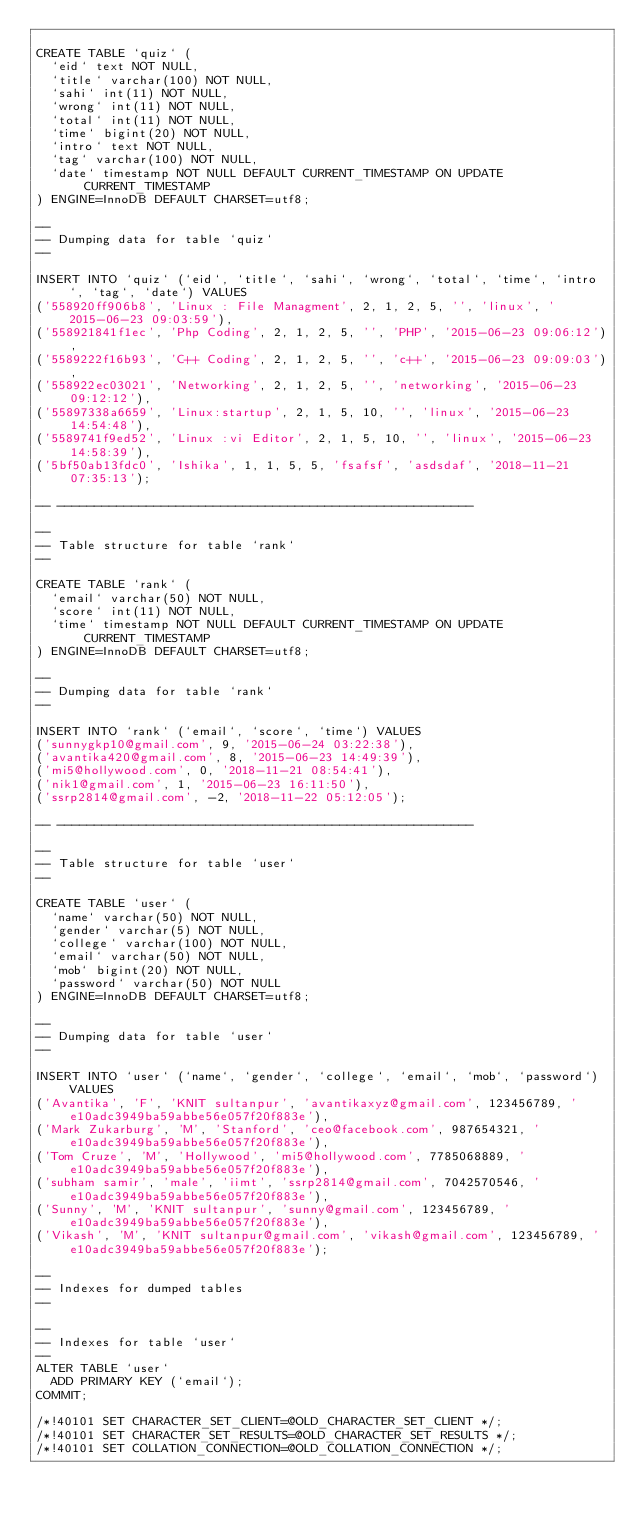<code> <loc_0><loc_0><loc_500><loc_500><_SQL_>
CREATE TABLE `quiz` (
  `eid` text NOT NULL,
  `title` varchar(100) NOT NULL,
  `sahi` int(11) NOT NULL,
  `wrong` int(11) NOT NULL,
  `total` int(11) NOT NULL,
  `time` bigint(20) NOT NULL,
  `intro` text NOT NULL,
  `tag` varchar(100) NOT NULL,
  `date` timestamp NOT NULL DEFAULT CURRENT_TIMESTAMP ON UPDATE CURRENT_TIMESTAMP
) ENGINE=InnoDB DEFAULT CHARSET=utf8;

--
-- Dumping data for table `quiz`
--

INSERT INTO `quiz` (`eid`, `title`, `sahi`, `wrong`, `total`, `time`, `intro`, `tag`, `date`) VALUES
('558920ff906b8', 'Linux : File Managment', 2, 1, 2, 5, '', 'linux', '2015-06-23 09:03:59'),
('558921841f1ec', 'Php Coding', 2, 1, 2, 5, '', 'PHP', '2015-06-23 09:06:12'),
('5589222f16b93', 'C++ Coding', 2, 1, 2, 5, '', 'c++', '2015-06-23 09:09:03'),
('558922ec03021', 'Networking', 2, 1, 2, 5, '', 'networking', '2015-06-23 09:12:12'),
('55897338a6659', 'Linux:startup', 2, 1, 5, 10, '', 'linux', '2015-06-23 14:54:48'),
('5589741f9ed52', 'Linux :vi Editor', 2, 1, 5, 10, '', 'linux', '2015-06-23 14:58:39'),
('5bf50ab13fdc0', 'Ishika', 1, 1, 5, 5, 'fsafsf', 'asdsdaf', '2018-11-21 07:35:13');

-- --------------------------------------------------------

--
-- Table structure for table `rank`
--

CREATE TABLE `rank` (
  `email` varchar(50) NOT NULL,
  `score` int(11) NOT NULL,
  `time` timestamp NOT NULL DEFAULT CURRENT_TIMESTAMP ON UPDATE CURRENT_TIMESTAMP
) ENGINE=InnoDB DEFAULT CHARSET=utf8;

--
-- Dumping data for table `rank`
--

INSERT INTO `rank` (`email`, `score`, `time`) VALUES
('sunnygkp10@gmail.com', 9, '2015-06-24 03:22:38'),
('avantika420@gmail.com', 8, '2015-06-23 14:49:39'),
('mi5@hollywood.com', 0, '2018-11-21 08:54:41'),
('nik1@gmail.com', 1, '2015-06-23 16:11:50'),
('ssrp2814@gmail.com', -2, '2018-11-22 05:12:05');

-- --------------------------------------------------------

--
-- Table structure for table `user`
--

CREATE TABLE `user` (
  `name` varchar(50) NOT NULL,
  `gender` varchar(5) NOT NULL,
  `college` varchar(100) NOT NULL,
  `email` varchar(50) NOT NULL,
  `mob` bigint(20) NOT NULL,
  `password` varchar(50) NOT NULL
) ENGINE=InnoDB DEFAULT CHARSET=utf8;

--
-- Dumping data for table `user`
--

INSERT INTO `user` (`name`, `gender`, `college`, `email`, `mob`, `password`) VALUES
('Avantika', 'F', 'KNIT sultanpur', 'avantikaxyz@gmail.com', 123456789, 'e10adc3949ba59abbe56e057f20f883e'),
('Mark Zukarburg', 'M', 'Stanford', 'ceo@facebook.com', 987654321, 'e10adc3949ba59abbe56e057f20f883e'),
('Tom Cruze', 'M', 'Hollywood', 'mi5@hollywood.com', 7785068889, 'e10adc3949ba59abbe56e057f20f883e'),
('subham samir', 'male', 'iimt', 'ssrp2814@gmail.com', 7042570546, 'e10adc3949ba59abbe56e057f20f883e'),
('Sunny', 'M', 'KNIT sultanpur', 'sunny@gmail.com', 123456789, 'e10adc3949ba59abbe56e057f20f883e'),
('Vikash', 'M', 'KNIT sultanpur@gmail.com', 'vikash@gmail.com', 123456789, 'e10adc3949ba59abbe56e057f20f883e');

--
-- Indexes for dumped tables
--

--
-- Indexes for table `user`
--
ALTER TABLE `user`
  ADD PRIMARY KEY (`email`);
COMMIT;

/*!40101 SET CHARACTER_SET_CLIENT=@OLD_CHARACTER_SET_CLIENT */;
/*!40101 SET CHARACTER_SET_RESULTS=@OLD_CHARACTER_SET_RESULTS */;
/*!40101 SET COLLATION_CONNECTION=@OLD_COLLATION_CONNECTION */;
</code> 